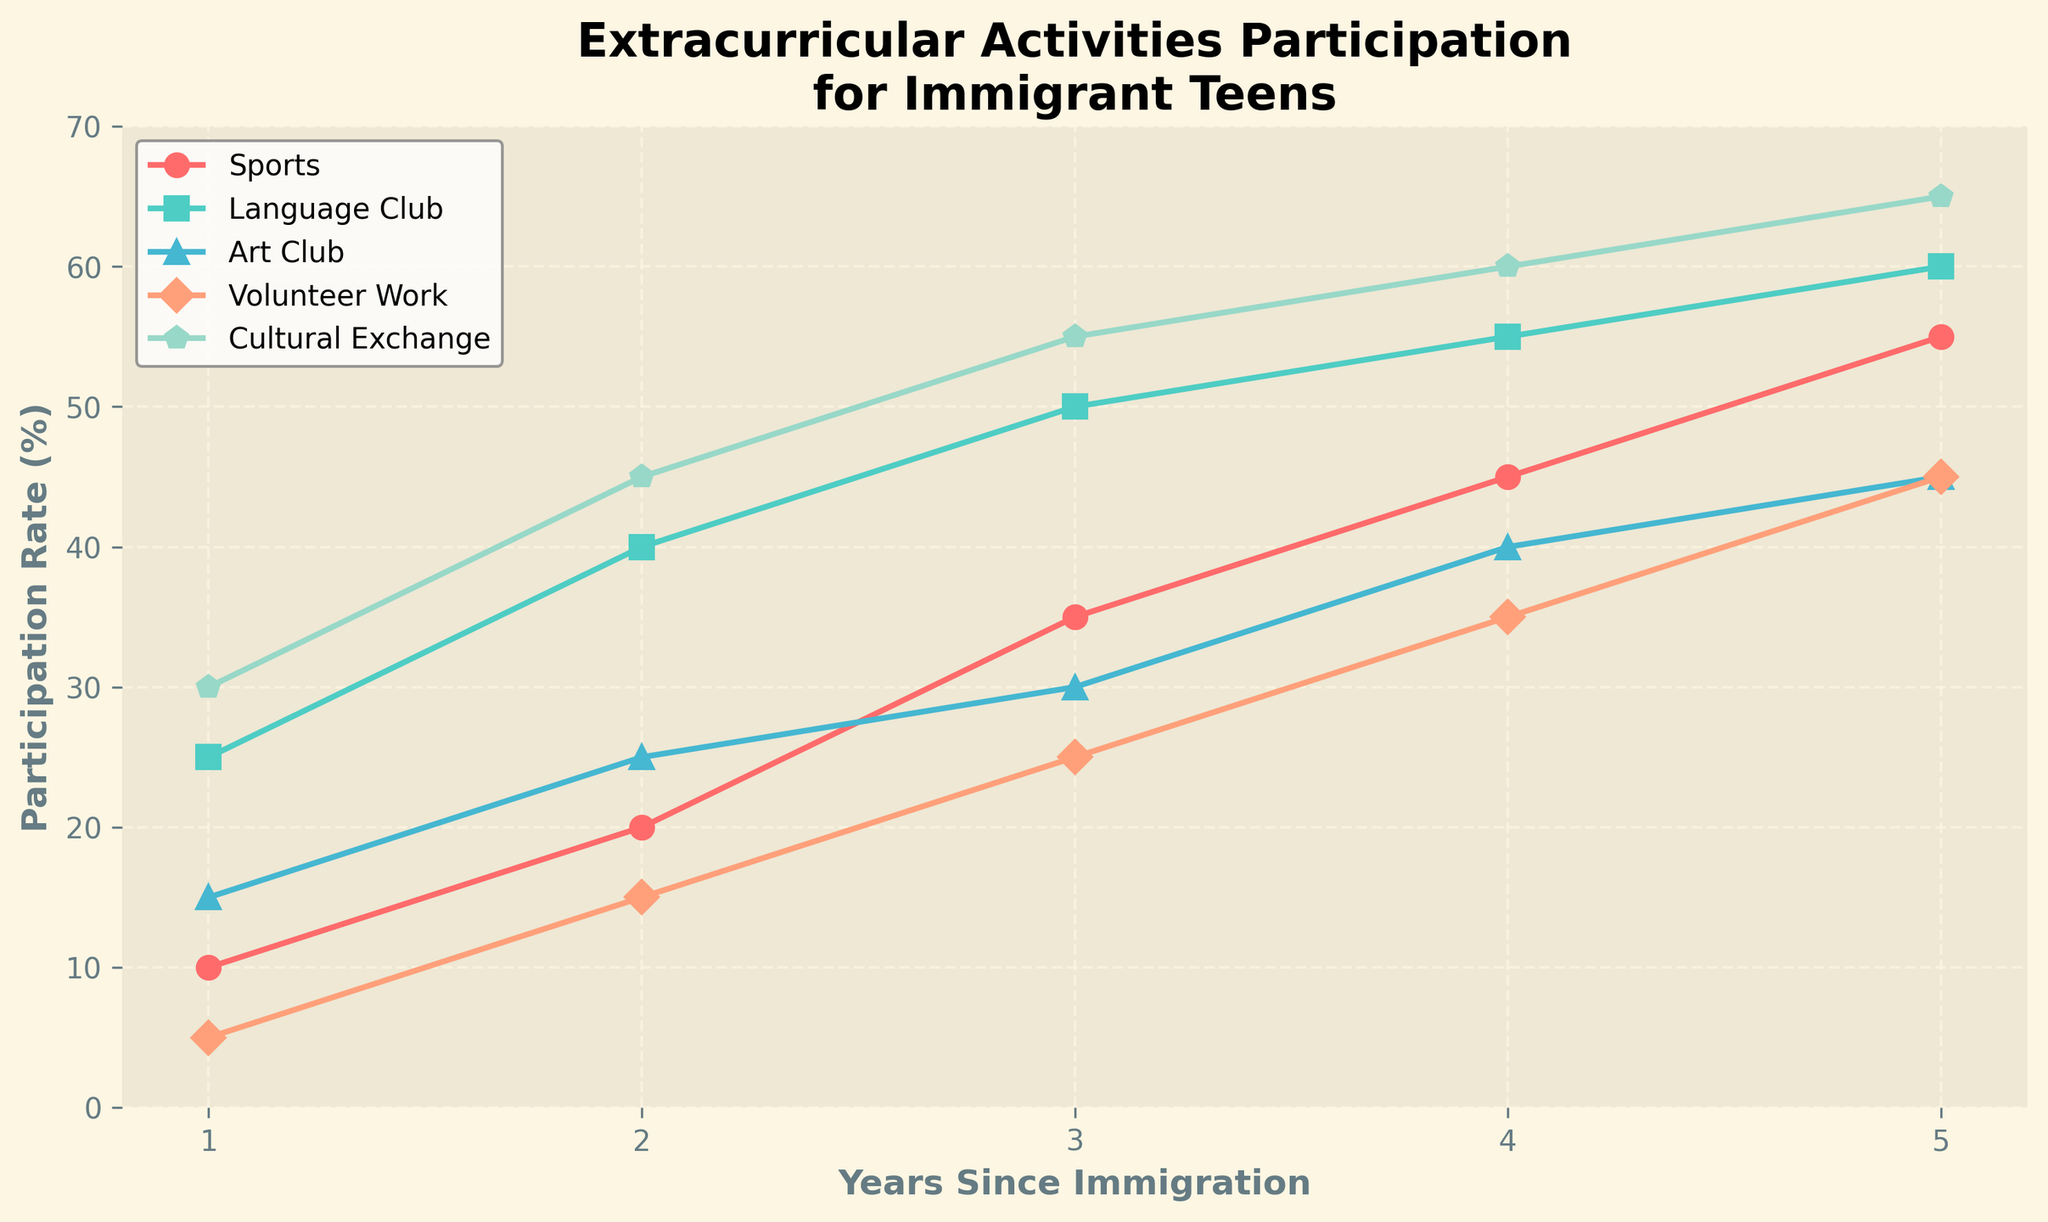What was the participation rate for sports in the second year? Look at the line labeled "Sports" on the graph. Find the point corresponding to the second year on the horizontal axis. The vertical axis value at that point represents the participation rate. It shows 20%.
Answer: 20% Which extracurricular activity had the highest participation rate in the first year? Identify which line or marker reaches the highest point on the vertical axis for the first year. The "Cultural Exchange" activity has the highest value at 30%.
Answer: Cultural Exchange How much did the participation in volunteer work increase from the first to the fifth year? Find the points for "Volunteer Work" at the first and fifth years. Subtract the first year's value (5%) from the fifth year's value (45%) to find the increase. 45% - 5% = 40%.
Answer: 40% Compare the participation rates of the Art Club and Language Club in the third year. Which one has a higher rate? Look for the points for "Art Club" and "Language Club" in the third year. The graph shows 30% for "Art Club" and 50% for "Language Club". Therefore, "Language Club" has a higher rate.
Answer: Language Club What is the average participation rate in Cultural Exchange activities over all five years? Sum the participation rates for "Cultural Exchange" in all five years: 30% + 45% + 55% + 60% + 65% = 255%. Then divide by 5 (255% / 5). The average rate is 51%.
Answer: 51% How does the participation rate in sports change from year 1 to year 4? Look at the changes in the "Sports" line from year 1 to year 4. It goes from 10% to 45%. The rate increases steadily over the years.
Answer: Increases steadily Which activity shows the least increase in participation rate over the five years? Calculate the increase for each activity from year 1 to year 5 and compare them. "Art Club" increases from 15% to 45% (30%), while all other activities have higher increases.
Answer: Art Club 